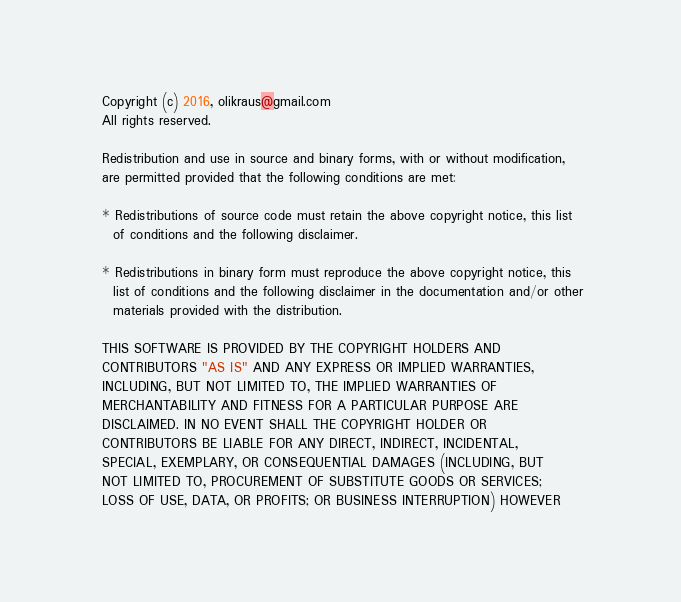Convert code to text. <code><loc_0><loc_0><loc_500><loc_500><_C_>
  Copyright (c) 2016, olikraus@gmail.com
  All rights reserved.

  Redistribution and use in source and binary forms, with or without modification, 
  are permitted provided that the following conditions are met:

  * Redistributions of source code must retain the above copyright notice, this list 
    of conditions and the following disclaimer.
    
  * Redistributions in binary form must reproduce the above copyright notice, this 
    list of conditions and the following disclaimer in the documentation and/or other 
    materials provided with the distribution.

  THIS SOFTWARE IS PROVIDED BY THE COPYRIGHT HOLDERS AND 
  CONTRIBUTORS "AS IS" AND ANY EXPRESS OR IMPLIED WARRANTIES, 
  INCLUDING, BUT NOT LIMITED TO, THE IMPLIED WARRANTIES OF 
  MERCHANTABILITY AND FITNESS FOR A PARTICULAR PURPOSE ARE 
  DISCLAIMED. IN NO EVENT SHALL THE COPYRIGHT HOLDER OR 
  CONTRIBUTORS BE LIABLE FOR ANY DIRECT, INDIRECT, INCIDENTAL, 
  SPECIAL, EXEMPLARY, OR CONSEQUENTIAL DAMAGES (INCLUDING, BUT 
  NOT LIMITED TO, PROCUREMENT OF SUBSTITUTE GOODS OR SERVICES; 
  LOSS OF USE, DATA, OR PROFITS; OR BUSINESS INTERRUPTION) HOWEVER </code> 